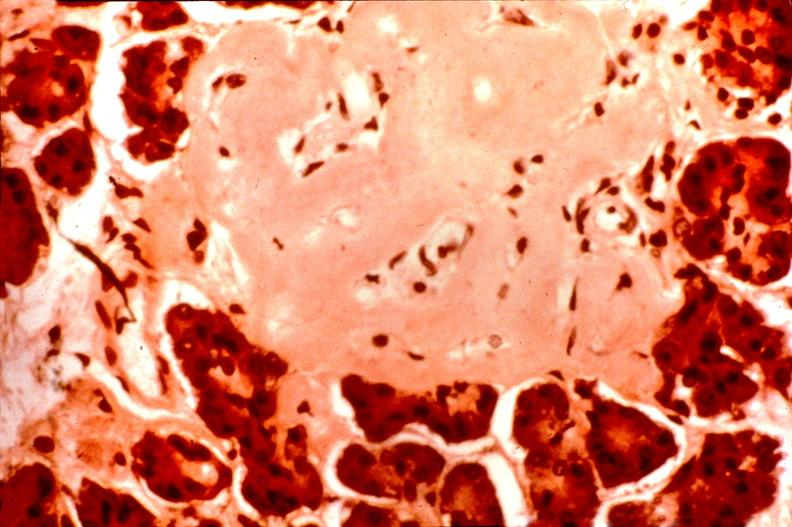s endocrine present?
Answer the question using a single word or phrase. Yes 